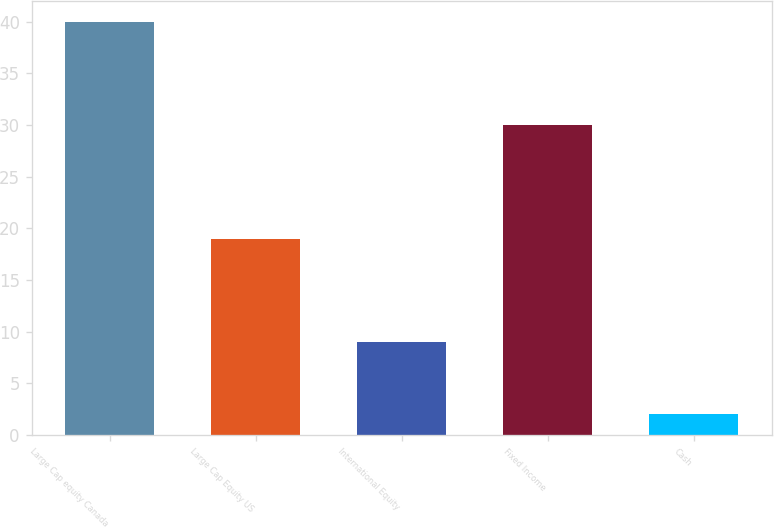Convert chart. <chart><loc_0><loc_0><loc_500><loc_500><bar_chart><fcel>Large Cap equity Canada<fcel>Large Cap Equity US<fcel>International Equity<fcel>Fixed Income<fcel>Cash<nl><fcel>40<fcel>19<fcel>9<fcel>30<fcel>2<nl></chart> 